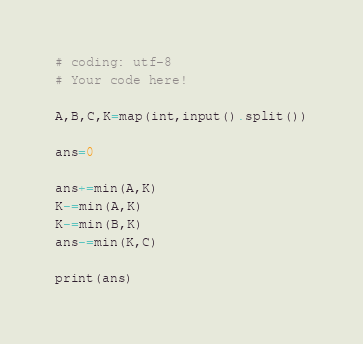Convert code to text. <code><loc_0><loc_0><loc_500><loc_500><_Python_># coding: utf-8
# Your code here!

A,B,C,K=map(int,input().split())

ans=0

ans+=min(A,K)
K-=min(A,K)
K-=min(B,K)
ans-=min(K,C)

print(ans)</code> 